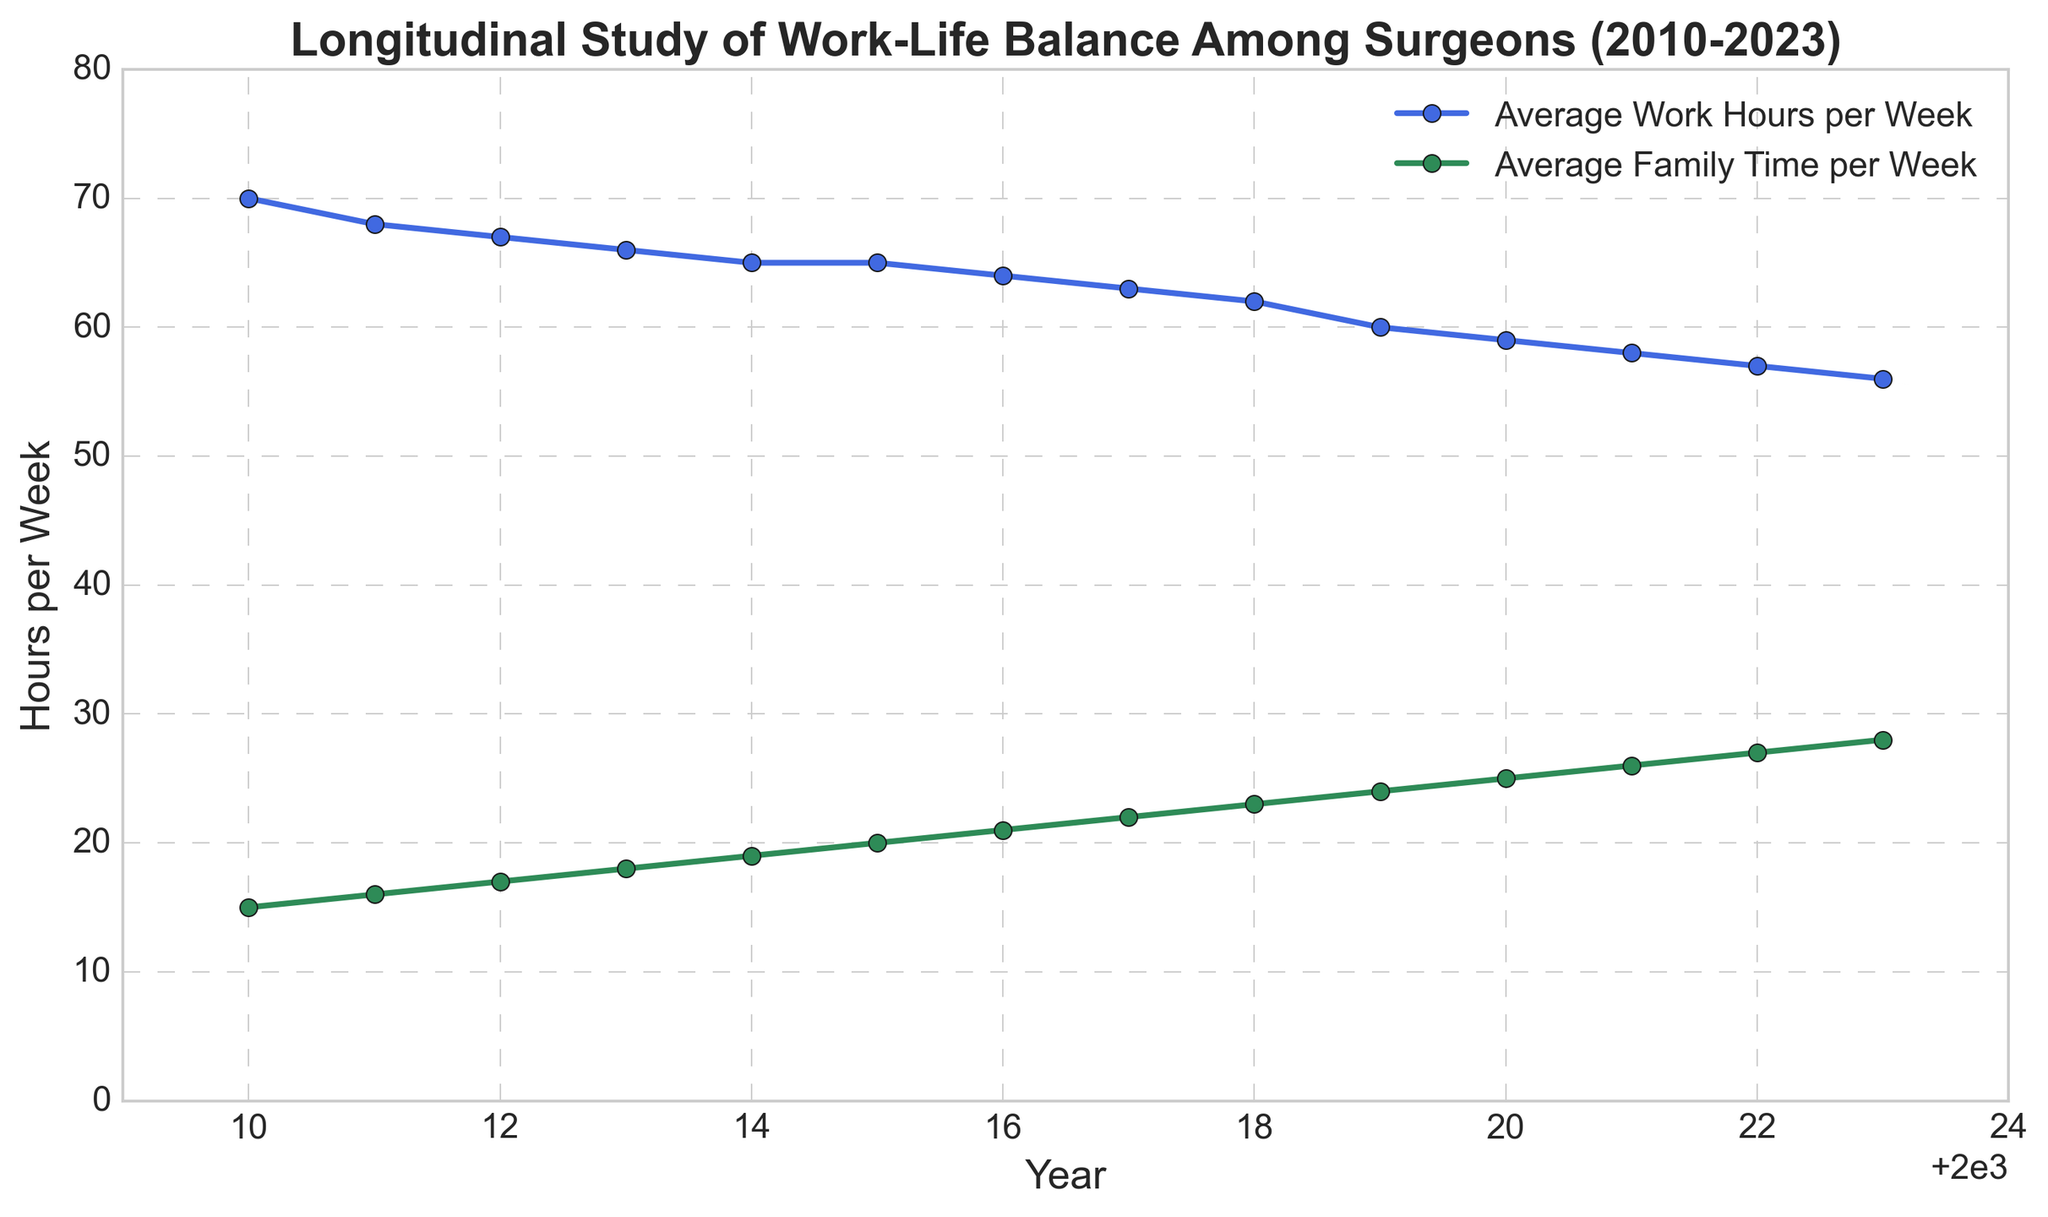What is the trend in average work hours per week over the years? The figure shows a downward slope for the line representing average work hours per week from 2010 to 2023. This indicates that the average work hours per week are decreasing over the years.
Answer: Decreasing How much family time did surgeons spend on average per week in 2022? By looking at the green line representing family time, the data point for the year 2022 shows that surgeons spent 27 hours per week with their families on average.
Answer: 27 hours In which year did surgeons experience the highest average family time per week? The highest point on the green line (family time) is at the end of the timeline in 2023, indicating that the highest average family time per week was in that year.
Answer: 2023 How many hours did surgeons reduce their average work hours per week from 2010 to 2023? The average work hours per week in 2010 were 70 hours and in 2023 were 56 hours. Therefore, the reduction is 70 - 56 = 14 hours.
Answer: 14 hours Compare the average work hours per week in 2014 to 2020. Did it increase or decrease, and by how much? In 2014, the average work hours were 65, and in 2020, it was 59. Hence, it decreased by 65 - 59 = 6 hours.
Answer: Decrease by 6 hours Find the difference in average family time per week between 2015 and 2020. The average family time in 2015 was 20 hours and in 2020 it was 25 hours. The difference is 25 - 20 = 5 hours.
Answer: 5 hours Which year experienced a crossover where average work hours per week stopped decreasing and remained constant for a year? By observing the blue line, we see that the line is flat between the years 2014 and 2015, indicating that the work hours remained constant at 65 hours per week during these years.
Answer: 2014-2015 What are the colors representing the work hours and family time lines? The plot uses a blue line to represent average work hours per week and a green line to represent average family time per week, as indicated by the line colors in the figure's legend.
Answer: Blue and green What is the range of years displayed on the X-axis? The figure shows years starting from 2010 to 2023 on the X-axis, as indicated by the labels.
Answer: 2010–2023 